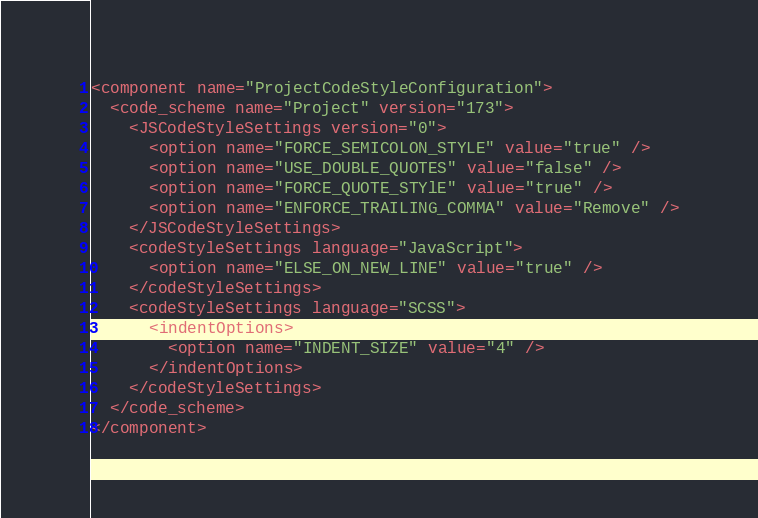Convert code to text. <code><loc_0><loc_0><loc_500><loc_500><_XML_><component name="ProjectCodeStyleConfiguration">
  <code_scheme name="Project" version="173">
    <JSCodeStyleSettings version="0">
      <option name="FORCE_SEMICOLON_STYLE" value="true" />
      <option name="USE_DOUBLE_QUOTES" value="false" />
      <option name="FORCE_QUOTE_STYlE" value="true" />
      <option name="ENFORCE_TRAILING_COMMA" value="Remove" />
    </JSCodeStyleSettings>
    <codeStyleSettings language="JavaScript">
      <option name="ELSE_ON_NEW_LINE" value="true" />
    </codeStyleSettings>
    <codeStyleSettings language="SCSS">
      <indentOptions>
        <option name="INDENT_SIZE" value="4" />
      </indentOptions>
    </codeStyleSettings>
  </code_scheme>
</component></code> 